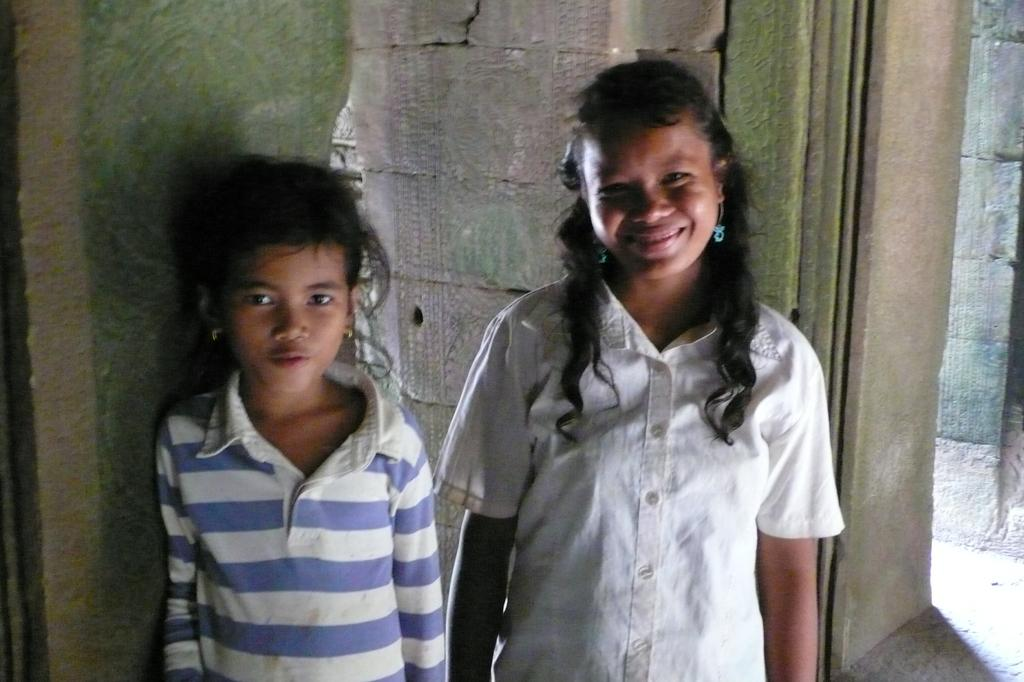How many kids are in the picture? There are two kids in the picture. What are the kids doing in the picture? The kids are standing and smiling. What can be seen in the background of the picture? There is a brick wall in the background of the picture. What type of yoke can be seen in the picture? There is no yoke present in the picture; it features two kids standing and smiling. How many times do the kids laugh in the picture? The kids are smiling, not laughing, in the picture. 